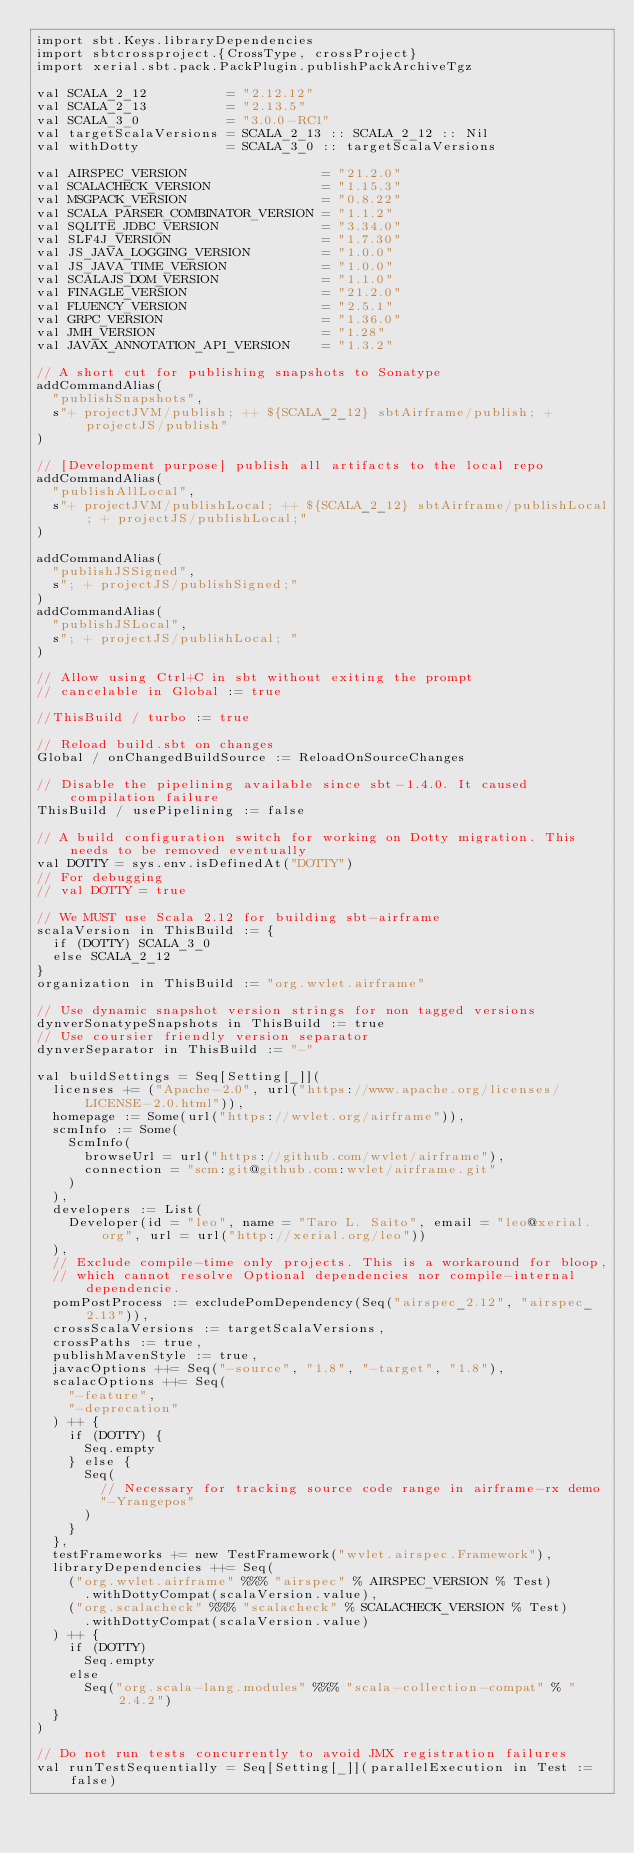<code> <loc_0><loc_0><loc_500><loc_500><_Scala_>import sbt.Keys.libraryDependencies
import sbtcrossproject.{CrossType, crossProject}
import xerial.sbt.pack.PackPlugin.publishPackArchiveTgz

val SCALA_2_12          = "2.12.12"
val SCALA_2_13          = "2.13.5"
val SCALA_3_0           = "3.0.0-RC1"
val targetScalaVersions = SCALA_2_13 :: SCALA_2_12 :: Nil
val withDotty           = SCALA_3_0 :: targetScalaVersions

val AIRSPEC_VERSION                 = "21.2.0"
val SCALACHECK_VERSION              = "1.15.3"
val MSGPACK_VERSION                 = "0.8.22"
val SCALA_PARSER_COMBINATOR_VERSION = "1.1.2"
val SQLITE_JDBC_VERSION             = "3.34.0"
val SLF4J_VERSION                   = "1.7.30"
val JS_JAVA_LOGGING_VERSION         = "1.0.0"
val JS_JAVA_TIME_VERSION            = "1.0.0"
val SCALAJS_DOM_VERSION             = "1.1.0"
val FINAGLE_VERSION                 = "21.2.0"
val FLUENCY_VERSION                 = "2.5.1"
val GRPC_VERSION                    = "1.36.0"
val JMH_VERSION                     = "1.28"
val JAVAX_ANNOTATION_API_VERSION    = "1.3.2"

// A short cut for publishing snapshots to Sonatype
addCommandAlias(
  "publishSnapshots",
  s"+ projectJVM/publish; ++ ${SCALA_2_12} sbtAirframe/publish; + projectJS/publish"
)

// [Development purpose] publish all artifacts to the local repo
addCommandAlias(
  "publishAllLocal",
  s"+ projectJVM/publishLocal; ++ ${SCALA_2_12} sbtAirframe/publishLocal; + projectJS/publishLocal;"
)

addCommandAlias(
  "publishJSSigned",
  s"; + projectJS/publishSigned;"
)
addCommandAlias(
  "publishJSLocal",
  s"; + projectJS/publishLocal; "
)

// Allow using Ctrl+C in sbt without exiting the prompt
// cancelable in Global := true

//ThisBuild / turbo := true

// Reload build.sbt on changes
Global / onChangedBuildSource := ReloadOnSourceChanges

// Disable the pipelining available since sbt-1.4.0. It caused compilation failure
ThisBuild / usePipelining := false

// A build configuration switch for working on Dotty migration. This needs to be removed eventually
val DOTTY = sys.env.isDefinedAt("DOTTY")
// For debugging
// val DOTTY = true

// We MUST use Scala 2.12 for building sbt-airframe
scalaVersion in ThisBuild := {
  if (DOTTY) SCALA_3_0
  else SCALA_2_12
}
organization in ThisBuild := "org.wvlet.airframe"

// Use dynamic snapshot version strings for non tagged versions
dynverSonatypeSnapshots in ThisBuild := true
// Use coursier friendly version separator
dynverSeparator in ThisBuild := "-"

val buildSettings = Seq[Setting[_]](
  licenses += ("Apache-2.0", url("https://www.apache.org/licenses/LICENSE-2.0.html")),
  homepage := Some(url("https://wvlet.org/airframe")),
  scmInfo := Some(
    ScmInfo(
      browseUrl = url("https://github.com/wvlet/airframe"),
      connection = "scm:git@github.com:wvlet/airframe.git"
    )
  ),
  developers := List(
    Developer(id = "leo", name = "Taro L. Saito", email = "leo@xerial.org", url = url("http://xerial.org/leo"))
  ),
  // Exclude compile-time only projects. This is a workaround for bloop,
  // which cannot resolve Optional dependencies nor compile-internal dependencie.
  pomPostProcess := excludePomDependency(Seq("airspec_2.12", "airspec_2.13")),
  crossScalaVersions := targetScalaVersions,
  crossPaths := true,
  publishMavenStyle := true,
  javacOptions ++= Seq("-source", "1.8", "-target", "1.8"),
  scalacOptions ++= Seq(
    "-feature",
    "-deprecation"
  ) ++ {
    if (DOTTY) {
      Seq.empty
    } else {
      Seq(
        // Necessary for tracking source code range in airframe-rx demo
        "-Yrangepos"
      )
    }
  },
  testFrameworks += new TestFramework("wvlet.airspec.Framework"),
  libraryDependencies ++= Seq(
    ("org.wvlet.airframe" %%% "airspec" % AIRSPEC_VERSION % Test)
      .withDottyCompat(scalaVersion.value),
    ("org.scalacheck" %%% "scalacheck" % SCALACHECK_VERSION % Test)
      .withDottyCompat(scalaVersion.value)
  ) ++ {
    if (DOTTY)
      Seq.empty
    else
      Seq("org.scala-lang.modules" %%% "scala-collection-compat" % "2.4.2")
  }
)

// Do not run tests concurrently to avoid JMX registration failures
val runTestSequentially = Seq[Setting[_]](parallelExecution in Test := false)
</code> 